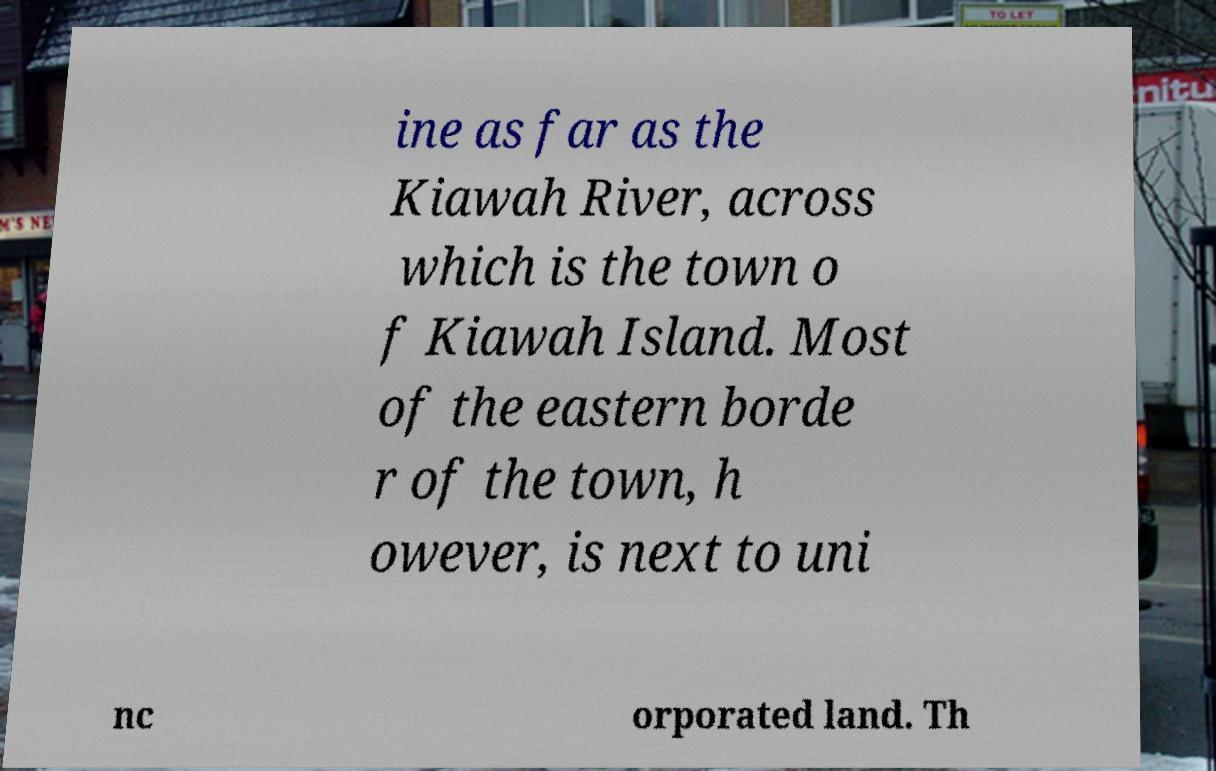Please read and relay the text visible in this image. What does it say? ine as far as the Kiawah River, across which is the town o f Kiawah Island. Most of the eastern borde r of the town, h owever, is next to uni nc orporated land. Th 